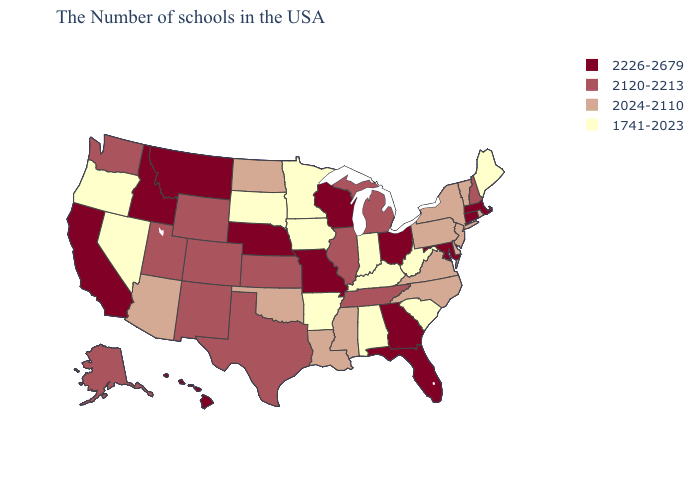Is the legend a continuous bar?
Answer briefly. No. What is the value of Hawaii?
Write a very short answer. 2226-2679. Does Utah have the highest value in the West?
Give a very brief answer. No. Which states have the lowest value in the USA?
Short answer required. Maine, South Carolina, West Virginia, Kentucky, Indiana, Alabama, Arkansas, Minnesota, Iowa, South Dakota, Nevada, Oregon. Does Mississippi have a higher value than Oregon?
Keep it brief. Yes. Name the states that have a value in the range 2226-2679?
Short answer required. Massachusetts, Connecticut, Maryland, Ohio, Florida, Georgia, Wisconsin, Missouri, Nebraska, Montana, Idaho, California, Hawaii. Which states have the lowest value in the MidWest?
Answer briefly. Indiana, Minnesota, Iowa, South Dakota. Name the states that have a value in the range 2024-2110?
Short answer required. Rhode Island, Vermont, New York, New Jersey, Delaware, Pennsylvania, Virginia, North Carolina, Mississippi, Louisiana, Oklahoma, North Dakota, Arizona. Does Indiana have the lowest value in the USA?
Answer briefly. Yes. Does the first symbol in the legend represent the smallest category?
Quick response, please. No. What is the lowest value in the South?
Answer briefly. 1741-2023. Name the states that have a value in the range 2120-2213?
Quick response, please. New Hampshire, Michigan, Tennessee, Illinois, Kansas, Texas, Wyoming, Colorado, New Mexico, Utah, Washington, Alaska. Name the states that have a value in the range 2120-2213?
Quick response, please. New Hampshire, Michigan, Tennessee, Illinois, Kansas, Texas, Wyoming, Colorado, New Mexico, Utah, Washington, Alaska. Does New Hampshire have a lower value than Arizona?
Keep it brief. No. What is the value of Illinois?
Be succinct. 2120-2213. 